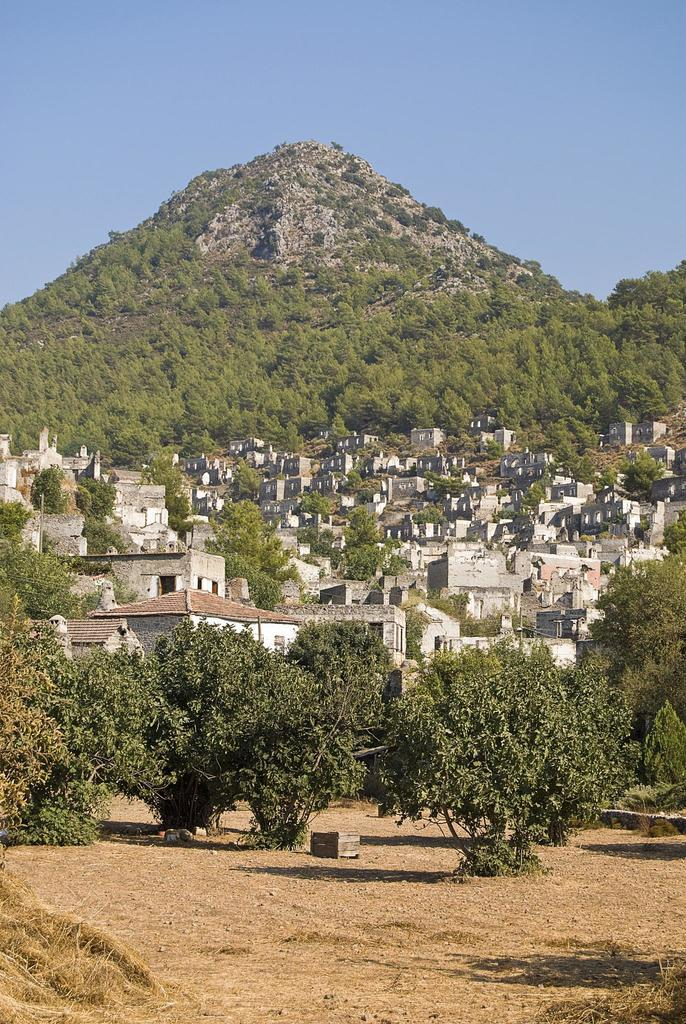What type of terrain is visible in the image? There is land in the image. What natural elements can be seen on the land? There are trees in the image. What structures are located behind the trees? There are houses behind the trees. What geographical feature is visible in the background of the image? There is a mountain in the background of the image. What type of tub is visible in the image? There is no tub present in the image. What musical instrument can be heard playing in the background of the image? There is no musical instrument playing in the background of the image. 